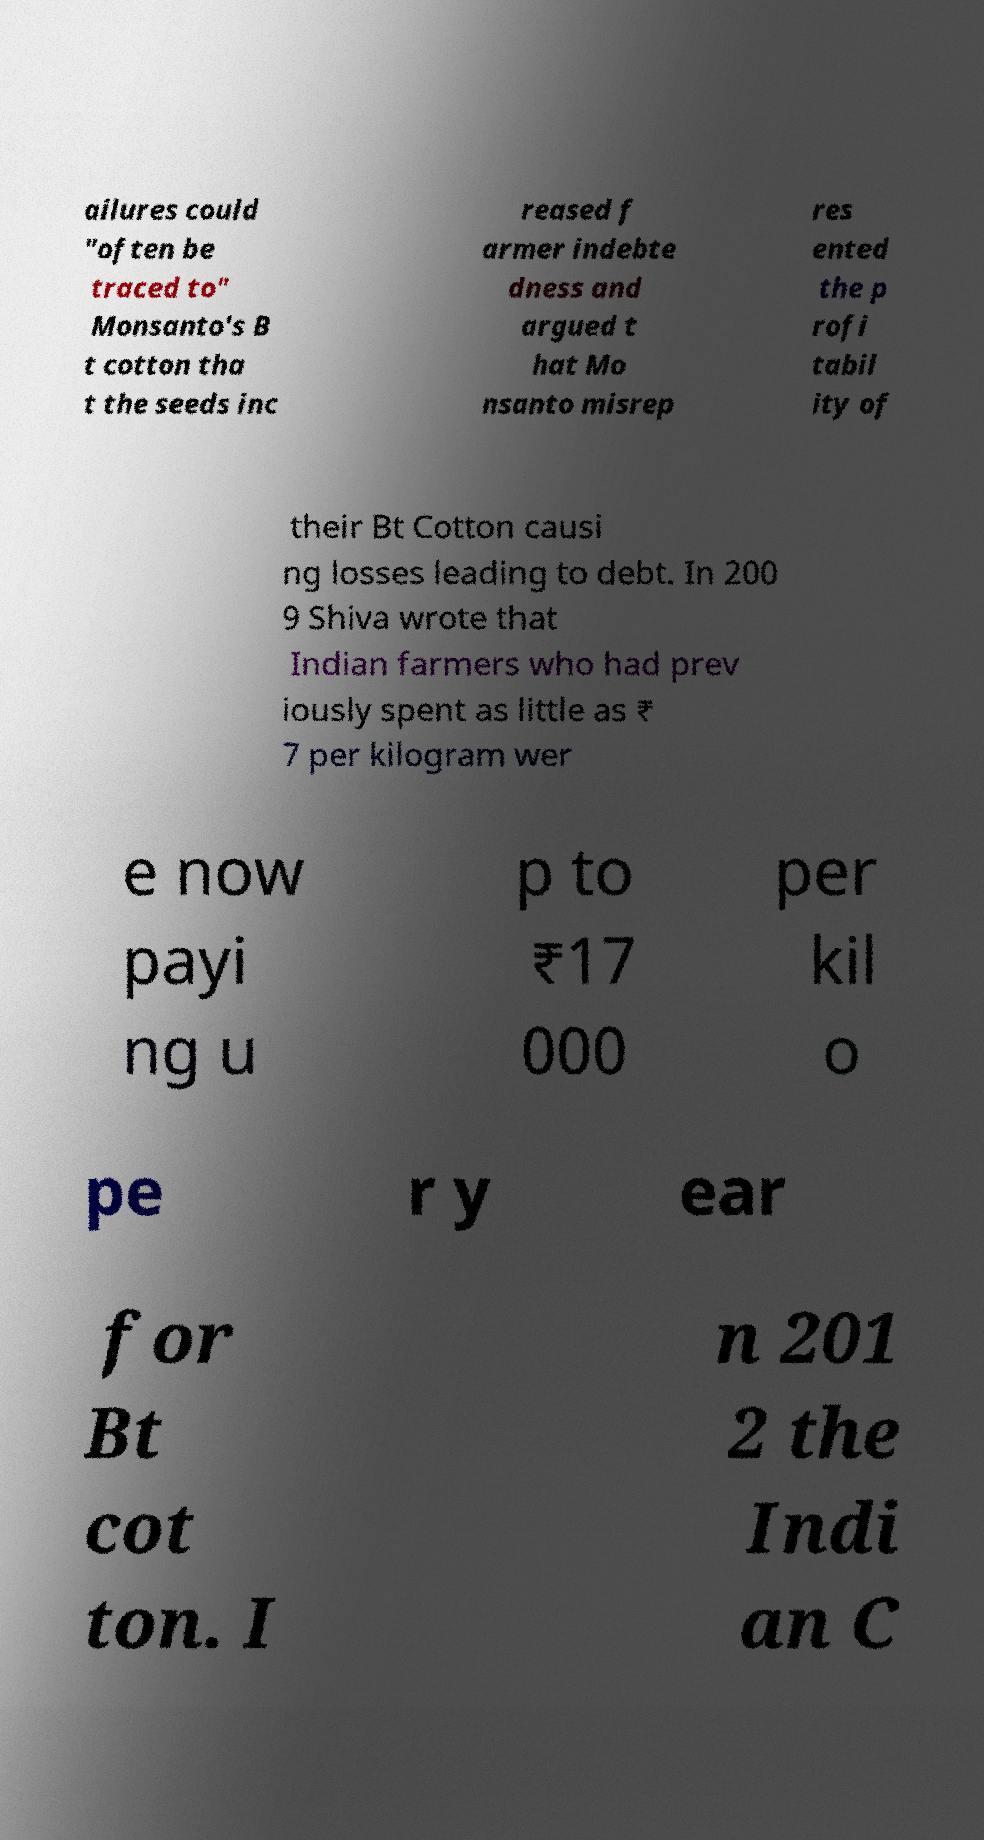There's text embedded in this image that I need extracted. Can you transcribe it verbatim? ailures could "often be traced to" Monsanto's B t cotton tha t the seeds inc reased f armer indebte dness and argued t hat Mo nsanto misrep res ented the p rofi tabil ity of their Bt Cotton causi ng losses leading to debt. In 200 9 Shiva wrote that Indian farmers who had prev iously spent as little as ₹ 7 per kilogram wer e now payi ng u p to ₹17 000 per kil o pe r y ear for Bt cot ton. I n 201 2 the Indi an C 